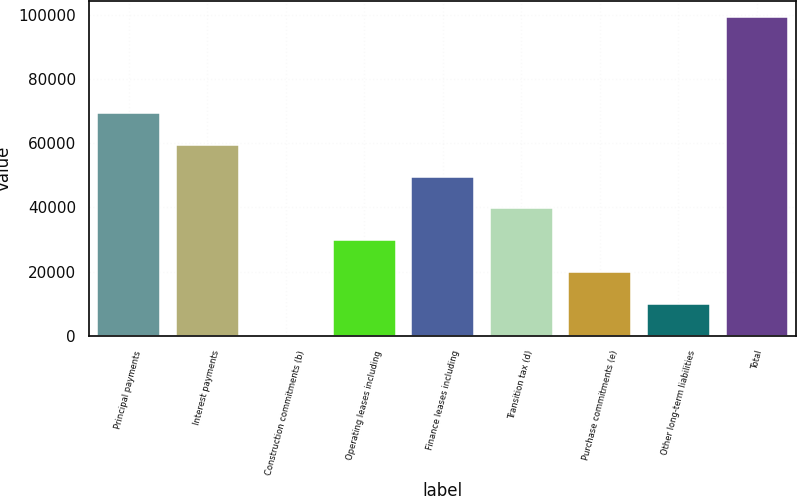<chart> <loc_0><loc_0><loc_500><loc_500><bar_chart><fcel>Principal payments<fcel>Interest payments<fcel>Construction commitments (b)<fcel>Operating leases including<fcel>Finance leases including<fcel>Transition tax (d)<fcel>Purchase commitments (e)<fcel>Other long-term liabilities<fcel>Total<nl><fcel>69466.6<fcel>59543.1<fcel>2.28<fcel>29772.7<fcel>49619.6<fcel>39696.2<fcel>19849.2<fcel>9925.75<fcel>99237<nl></chart> 